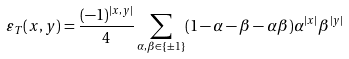Convert formula to latex. <formula><loc_0><loc_0><loc_500><loc_500>\varepsilon _ { T } ( x , y ) = \frac { ( - 1 ) ^ { | x , y | } } { 4 } \sum _ { \alpha , \beta \in \{ \pm 1 \} } ( 1 - \alpha - \beta - \alpha \beta ) \alpha ^ { | x | } \beta ^ { | y | }</formula> 